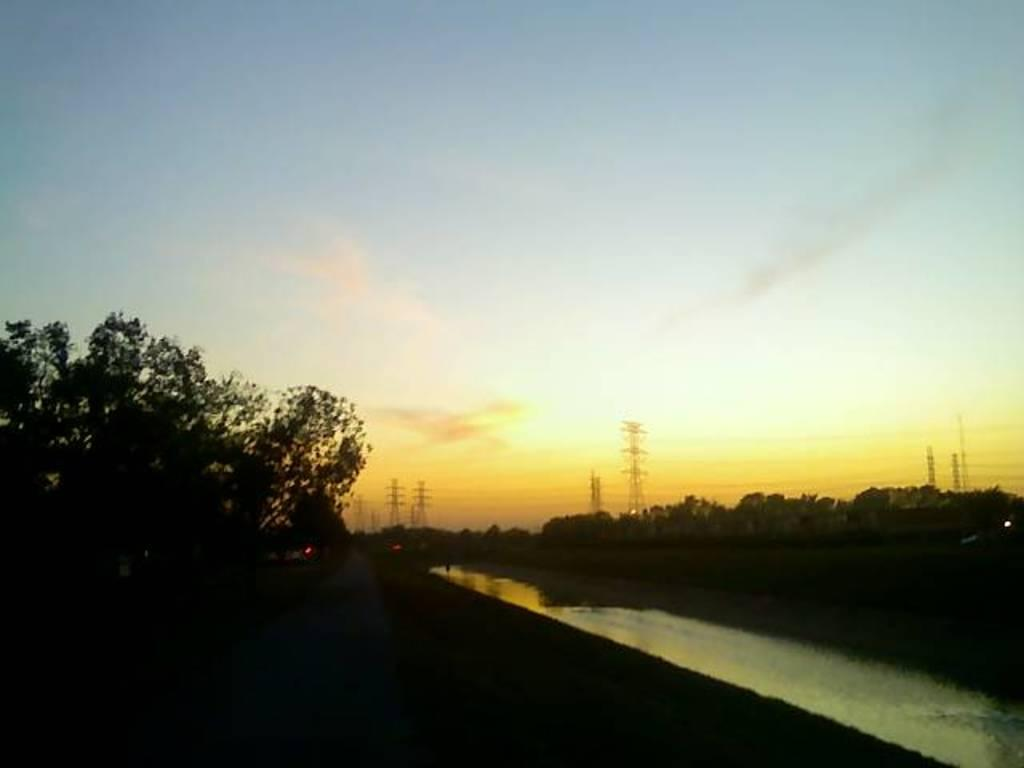What type of natural elements can be seen in the image? There are trees in the image. What man-made structures are present in the image? Transmission towers are present in the image. What connects the transmission towers in the image? Wires are visible in the image. What type of pathway is available for people in the image? There is a walkway in the image. What type of terrain is visible in the image? Water is present in the image. What is the appearance of the bottom of the image? The bottom of the image has a dark view. What is visible in the background of the image? The sky is visible in the background of the image. Can you see the tongue of the person walking on the walkway in the image? There is no person or tongue visible in the image. What type of attraction is present in the image? There is no attraction mentioned or visible in the image. 